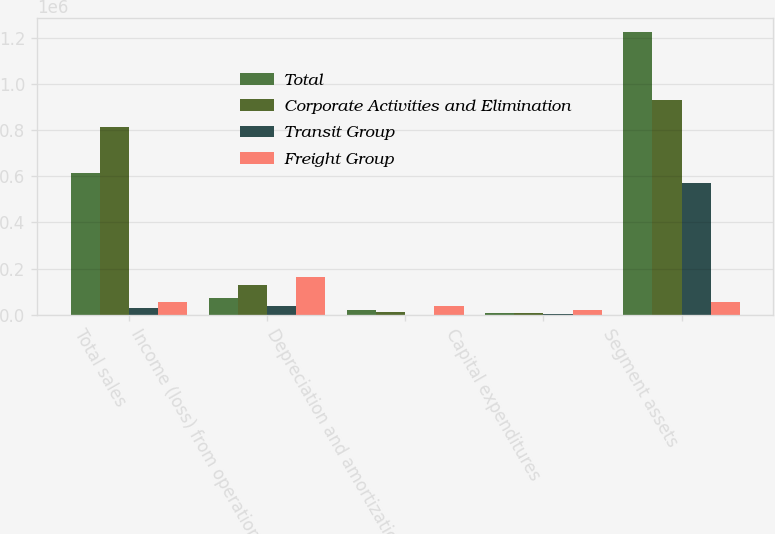Convert chart. <chart><loc_0><loc_0><loc_500><loc_500><stacked_bar_chart><ecel><fcel>Total sales<fcel>Income (loss) from operations<fcel>Depreciation and amortization<fcel>Capital expenditures<fcel>Segment assets<nl><fcel>Total<fcel>614439<fcel>74101<fcel>22128<fcel>9199<fcel>1.22614e+06<nl><fcel>Corporate Activities and Elimination<fcel>815659<fcel>128795<fcel>12940<fcel>7791<fcel>929855<nl><fcel>Transit Group<fcel>28482<fcel>39537<fcel>451<fcel>1298<fcel>570165<nl><fcel>Freight Group<fcel>56819<fcel>163359<fcel>35519<fcel>18288<fcel>56819<nl></chart> 